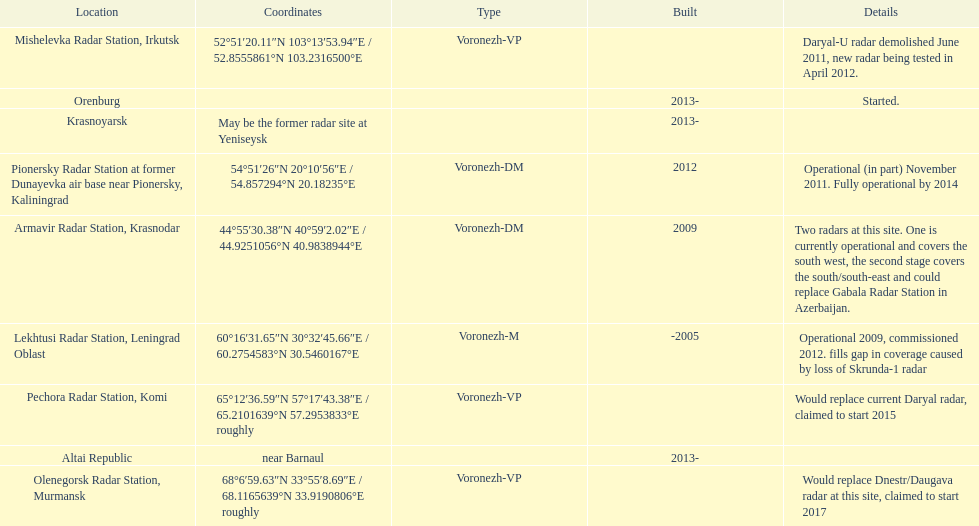What are the list of radar locations? Lekhtusi Radar Station, Leningrad Oblast, Armavir Radar Station, Krasnodar, Pionersky Radar Station at former Dunayevka air base near Pionersky, Kaliningrad, Mishelevka Radar Station, Irkutsk, Pechora Radar Station, Komi, Olenegorsk Radar Station, Murmansk, Krasnoyarsk, Altai Republic, Orenburg. Which of these are claimed to start in 2015? Pechora Radar Station, Komi. 